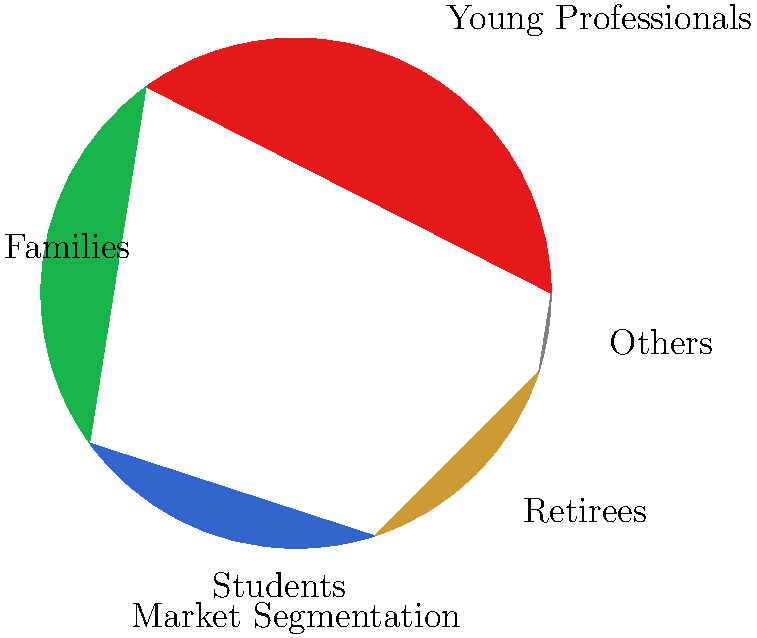Based on the market segmentation pie chart, which two customer groups combined represent 60% of your target market? How might this information influence your strategy to reach new markets? To answer this question, we need to analyze the pie chart and follow these steps:

1. Identify the percentages for each customer group:
   - Young Professionals: 35%
   - Families: 25%
   - Students: 20%
   - Retirees: 15%
   - Others: 5%

2. Find the two groups that, when combined, equal 60%:
   - Young Professionals (35%) + Families (25%) = 60%

3. Consider the strategic implications:
   a) These two groups represent the majority of the target market, indicating where most resources should be allocated.
   b) Tailoring marketing messages and product features to appeal to both young professionals and families could maximize reach and effectiveness.
   c) There may be opportunities to create products or services that cater to the overlapping needs of these two groups.
   d) When expanding to new markets, look for areas with high concentrations of young professionals and families.
   e) Consider partnerships or collaborations that are popular among these two demographic groups.
   f) Develop customer personas for these two groups to better understand their needs, preferences, and behaviors.
   g) Analyze the remaining 40% of the market for potential growth opportunities or niche markets.
Answer: Young Professionals and Families; focus marketing and product development on these groups' needs and preferences while exploring opportunities in other segments. 